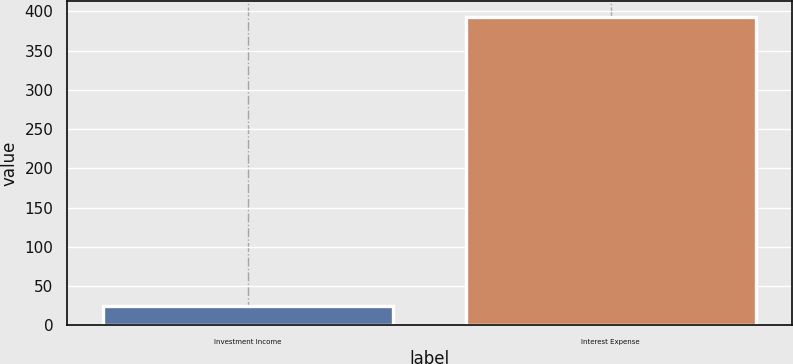<chart> <loc_0><loc_0><loc_500><loc_500><bar_chart><fcel>Investment Income<fcel>Interest Expense<nl><fcel>24<fcel>393<nl></chart> 